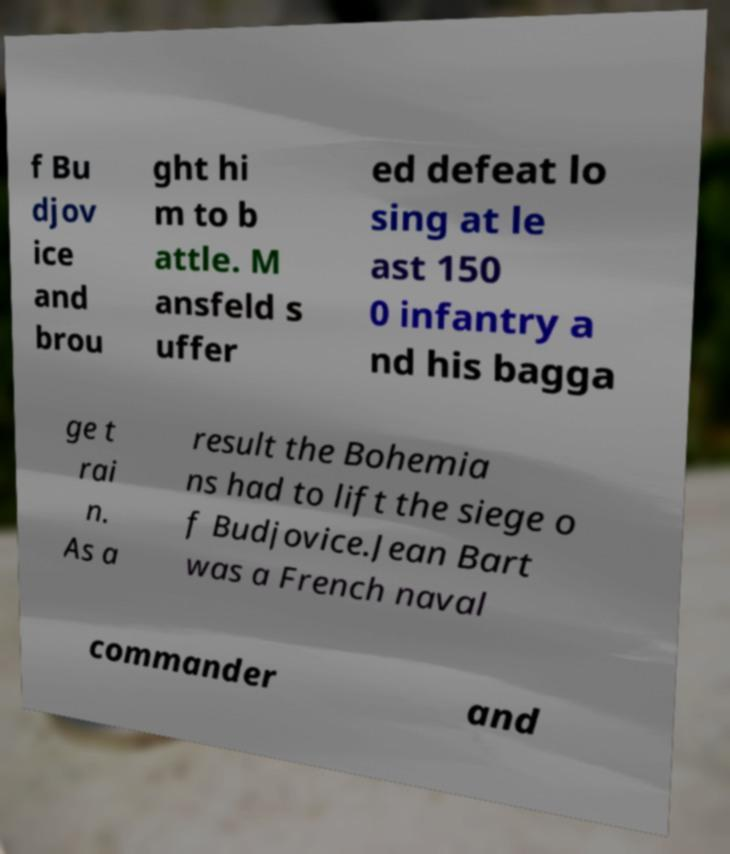Can you read and provide the text displayed in the image?This photo seems to have some interesting text. Can you extract and type it out for me? f Bu djov ice and brou ght hi m to b attle. M ansfeld s uffer ed defeat lo sing at le ast 150 0 infantry a nd his bagga ge t rai n. As a result the Bohemia ns had to lift the siege o f Budjovice.Jean Bart was a French naval commander and 